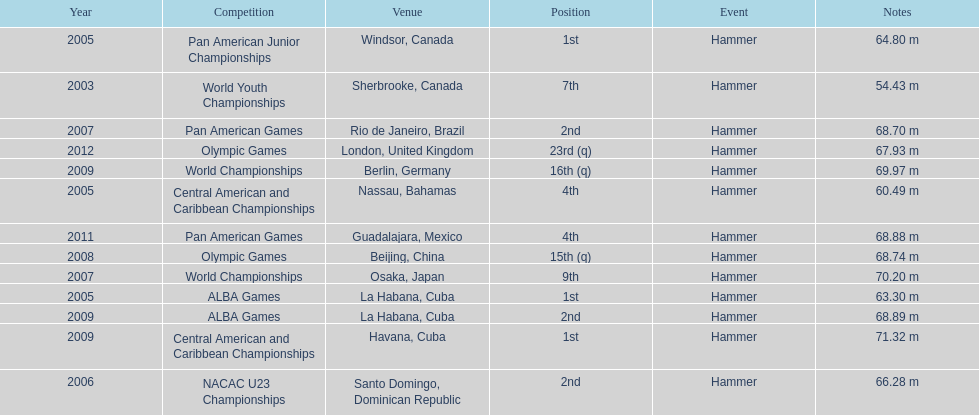In which olympic games did arasay thondike not finish in the top 20? 2012. 